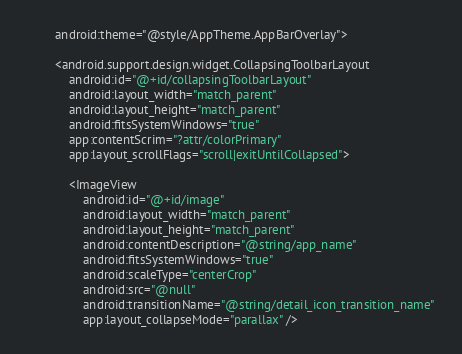<code> <loc_0><loc_0><loc_500><loc_500><_XML_>        android:theme="@style/AppTheme.AppBarOverlay">

        <android.support.design.widget.CollapsingToolbarLayout
            android:id="@+id/collapsingToolbarLayout"
            android:layout_width="match_parent"
            android:layout_height="match_parent"
            android:fitsSystemWindows="true"
            app:contentScrim="?attr/colorPrimary"
            app:layout_scrollFlags="scroll|exitUntilCollapsed">

            <ImageView
                android:id="@+id/image"
                android:layout_width="match_parent"
                android:layout_height="match_parent"
                android:contentDescription="@string/app_name"
                android:fitsSystemWindows="true"
                android:scaleType="centerCrop"
                android:src="@null"
                android:transitionName="@string/detail_icon_transition_name"
                app:layout_collapseMode="parallax" />
</code> 